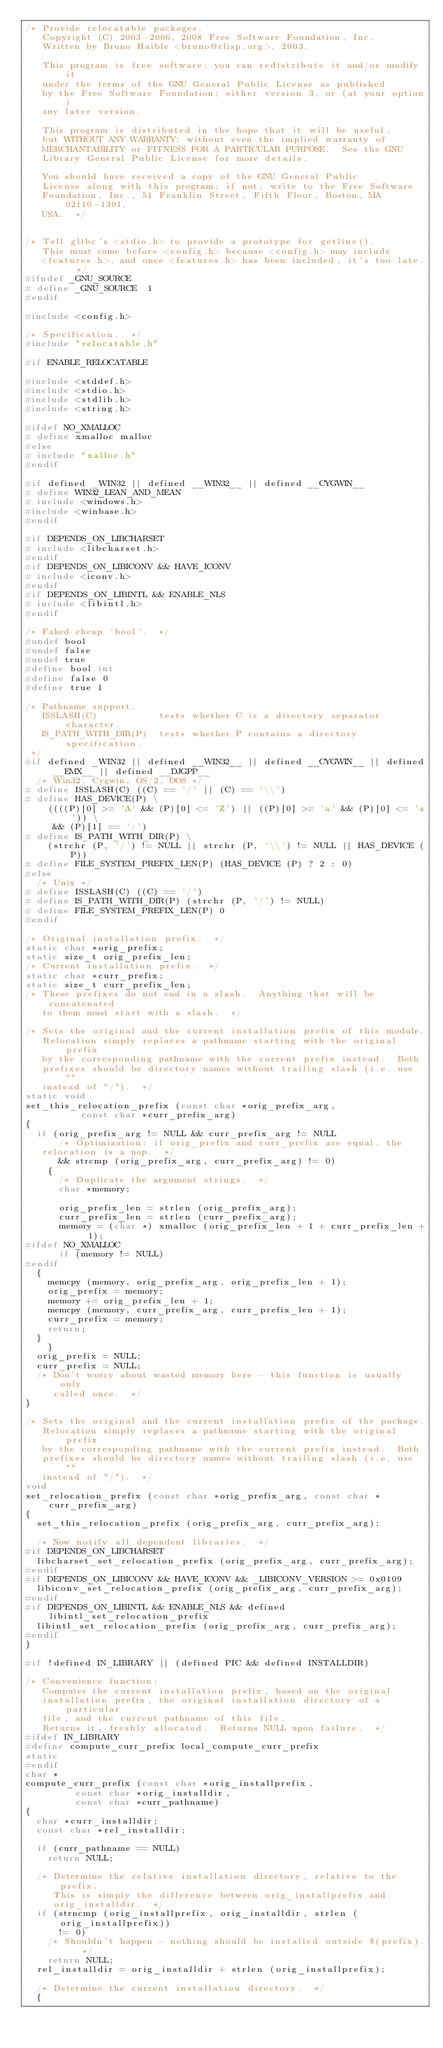<code> <loc_0><loc_0><loc_500><loc_500><_C_>/* Provide relocatable packages.
   Copyright (C) 2003-2006, 2008 Free Software Foundation, Inc.
   Written by Bruno Haible <bruno@clisp.org>, 2003.

   This program is free software; you can redistribute it and/or modify it
   under the terms of the GNU General Public License as published
   by the Free Software Foundation; either version 3, or (at your option)
   any later version.

   This program is distributed in the hope that it will be useful,
   but WITHOUT ANY WARRANTY; without even the implied warranty of
   MERCHANTABILITY or FITNESS FOR A PARTICULAR PURPOSE.  See the GNU
   Library General Public License for more details.

   You should have received a copy of the GNU General Public
   License along with this program; if not, write to the Free Software
   Foundation, Inc., 51 Franklin Street, Fifth Floor, Boston, MA 02110-1301,
   USA.  */


/* Tell glibc's <stdio.h> to provide a prototype for getline().
   This must come before <config.h> because <config.h> may include
   <features.h>, and once <features.h> has been included, it's too late.  */
#ifndef _GNU_SOURCE
# define _GNU_SOURCE	1
#endif

#include <config.h>

/* Specification.  */
#include "relocatable.h"

#if ENABLE_RELOCATABLE

#include <stddef.h>
#include <stdio.h>
#include <stdlib.h>
#include <string.h>

#ifdef NO_XMALLOC
# define xmalloc malloc
#else
# include "xalloc.h"
#endif

#if defined _WIN32 || defined __WIN32__ || defined __CYGWIN__
# define WIN32_LEAN_AND_MEAN
# include <windows.h>
#include <winbase.h>
#endif

#if DEPENDS_ON_LIBCHARSET
# include <libcharset.h>
#endif
#if DEPENDS_ON_LIBICONV && HAVE_ICONV
# include <iconv.h>
#endif
#if DEPENDS_ON_LIBINTL && ENABLE_NLS
# include <libintl.h>
#endif

/* Faked cheap 'bool'.  */
#undef bool
#undef false
#undef true
#define bool int
#define false 0
#define true 1

/* Pathname support.
   ISSLASH(C)           tests whether C is a directory separator character.
   IS_PATH_WITH_DIR(P)  tests whether P contains a directory specification.
 */
#if defined _WIN32 || defined __WIN32__ || defined __CYGWIN__ || defined __EMX__ || defined __DJGPP__
  /* Win32, Cygwin, OS/2, DOS */
# define ISSLASH(C) ((C) == '/' || (C) == '\\')
# define HAS_DEVICE(P) \
    ((((P)[0] >= 'A' && (P)[0] <= 'Z') || ((P)[0] >= 'a' && (P)[0] <= 'z')) \
     && (P)[1] == ':')
# define IS_PATH_WITH_DIR(P) \
    (strchr (P, '/') != NULL || strchr (P, '\\') != NULL || HAS_DEVICE (P))
# define FILE_SYSTEM_PREFIX_LEN(P) (HAS_DEVICE (P) ? 2 : 0)
#else
  /* Unix */
# define ISSLASH(C) ((C) == '/')
# define IS_PATH_WITH_DIR(P) (strchr (P, '/') != NULL)
# define FILE_SYSTEM_PREFIX_LEN(P) 0
#endif

/* Original installation prefix.  */
static char *orig_prefix;
static size_t orig_prefix_len;
/* Current installation prefix.  */
static char *curr_prefix;
static size_t curr_prefix_len;
/* These prefixes do not end in a slash.  Anything that will be concatenated
   to them must start with a slash.  */

/* Sets the original and the current installation prefix of this module.
   Relocation simply replaces a pathname starting with the original prefix
   by the corresponding pathname with the current prefix instead.  Both
   prefixes should be directory names without trailing slash (i.e. use ""
   instead of "/").  */
static void
set_this_relocation_prefix (const char *orig_prefix_arg,
			    const char *curr_prefix_arg)
{
  if (orig_prefix_arg != NULL && curr_prefix_arg != NULL
      /* Optimization: if orig_prefix and curr_prefix are equal, the
	 relocation is a nop.  */
      && strcmp (orig_prefix_arg, curr_prefix_arg) != 0)
    {
      /* Duplicate the argument strings.  */
      char *memory;

      orig_prefix_len = strlen (orig_prefix_arg);
      curr_prefix_len = strlen (curr_prefix_arg);
      memory = (char *) xmalloc (orig_prefix_len + 1 + curr_prefix_len + 1);
#ifdef NO_XMALLOC
      if (memory != NULL)
#endif
	{
	  memcpy (memory, orig_prefix_arg, orig_prefix_len + 1);
	  orig_prefix = memory;
	  memory += orig_prefix_len + 1;
	  memcpy (memory, curr_prefix_arg, curr_prefix_len + 1);
	  curr_prefix = memory;
	  return;
	}
    }
  orig_prefix = NULL;
  curr_prefix = NULL;
  /* Don't worry about wasted memory here - this function is usually only
     called once.  */
}

/* Sets the original and the current installation prefix of the package.
   Relocation simply replaces a pathname starting with the original prefix
   by the corresponding pathname with the current prefix instead.  Both
   prefixes should be directory names without trailing slash (i.e. use ""
   instead of "/").  */
void
set_relocation_prefix (const char *orig_prefix_arg, const char *curr_prefix_arg)
{
  set_this_relocation_prefix (orig_prefix_arg, curr_prefix_arg);

  /* Now notify all dependent libraries.  */
#if DEPENDS_ON_LIBCHARSET
  libcharset_set_relocation_prefix (orig_prefix_arg, curr_prefix_arg);
#endif
#if DEPENDS_ON_LIBICONV && HAVE_ICONV && _LIBICONV_VERSION >= 0x0109
  libiconv_set_relocation_prefix (orig_prefix_arg, curr_prefix_arg);
#endif
#if DEPENDS_ON_LIBINTL && ENABLE_NLS && defined libintl_set_relocation_prefix
  libintl_set_relocation_prefix (orig_prefix_arg, curr_prefix_arg);
#endif
}

#if !defined IN_LIBRARY || (defined PIC && defined INSTALLDIR)

/* Convenience function:
   Computes the current installation prefix, based on the original
   installation prefix, the original installation directory of a particular
   file, and the current pathname of this file.
   Returns it, freshly allocated.  Returns NULL upon failure.  */
#ifdef IN_LIBRARY
#define compute_curr_prefix local_compute_curr_prefix
static
#endif
char *
compute_curr_prefix (const char *orig_installprefix,
		     const char *orig_installdir,
		     const char *curr_pathname)
{
  char *curr_installdir;
  const char *rel_installdir;

  if (curr_pathname == NULL)
    return NULL;

  /* Determine the relative installation directory, relative to the prefix.
     This is simply the difference between orig_installprefix and
     orig_installdir.  */
  if (strncmp (orig_installprefix, orig_installdir, strlen (orig_installprefix))
      != 0)
    /* Shouldn't happen - nothing should be installed outside $(prefix).  */
    return NULL;
  rel_installdir = orig_installdir + strlen (orig_installprefix);

  /* Determine the current installation directory.  */
  {</code> 